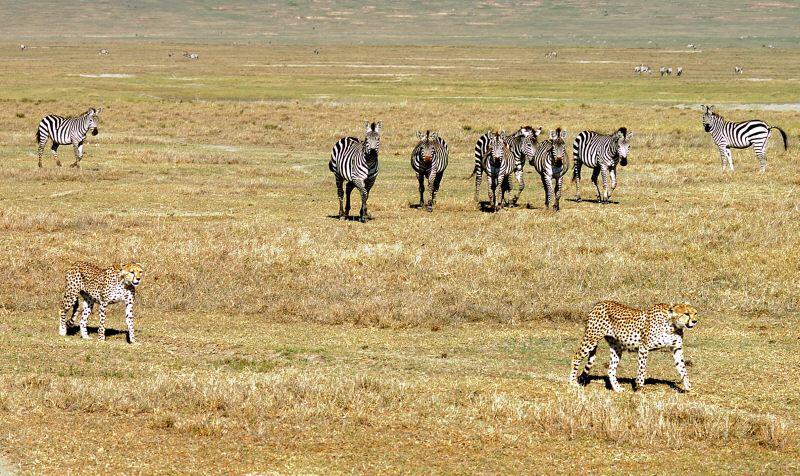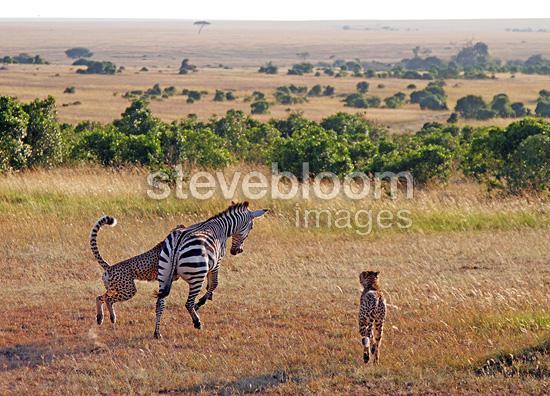The first image is the image on the left, the second image is the image on the right. For the images shown, is this caption "One image shows a single cheetah behind at least one zebra and bounding rightward across the field towards the zebra." true? Answer yes or no. No. 